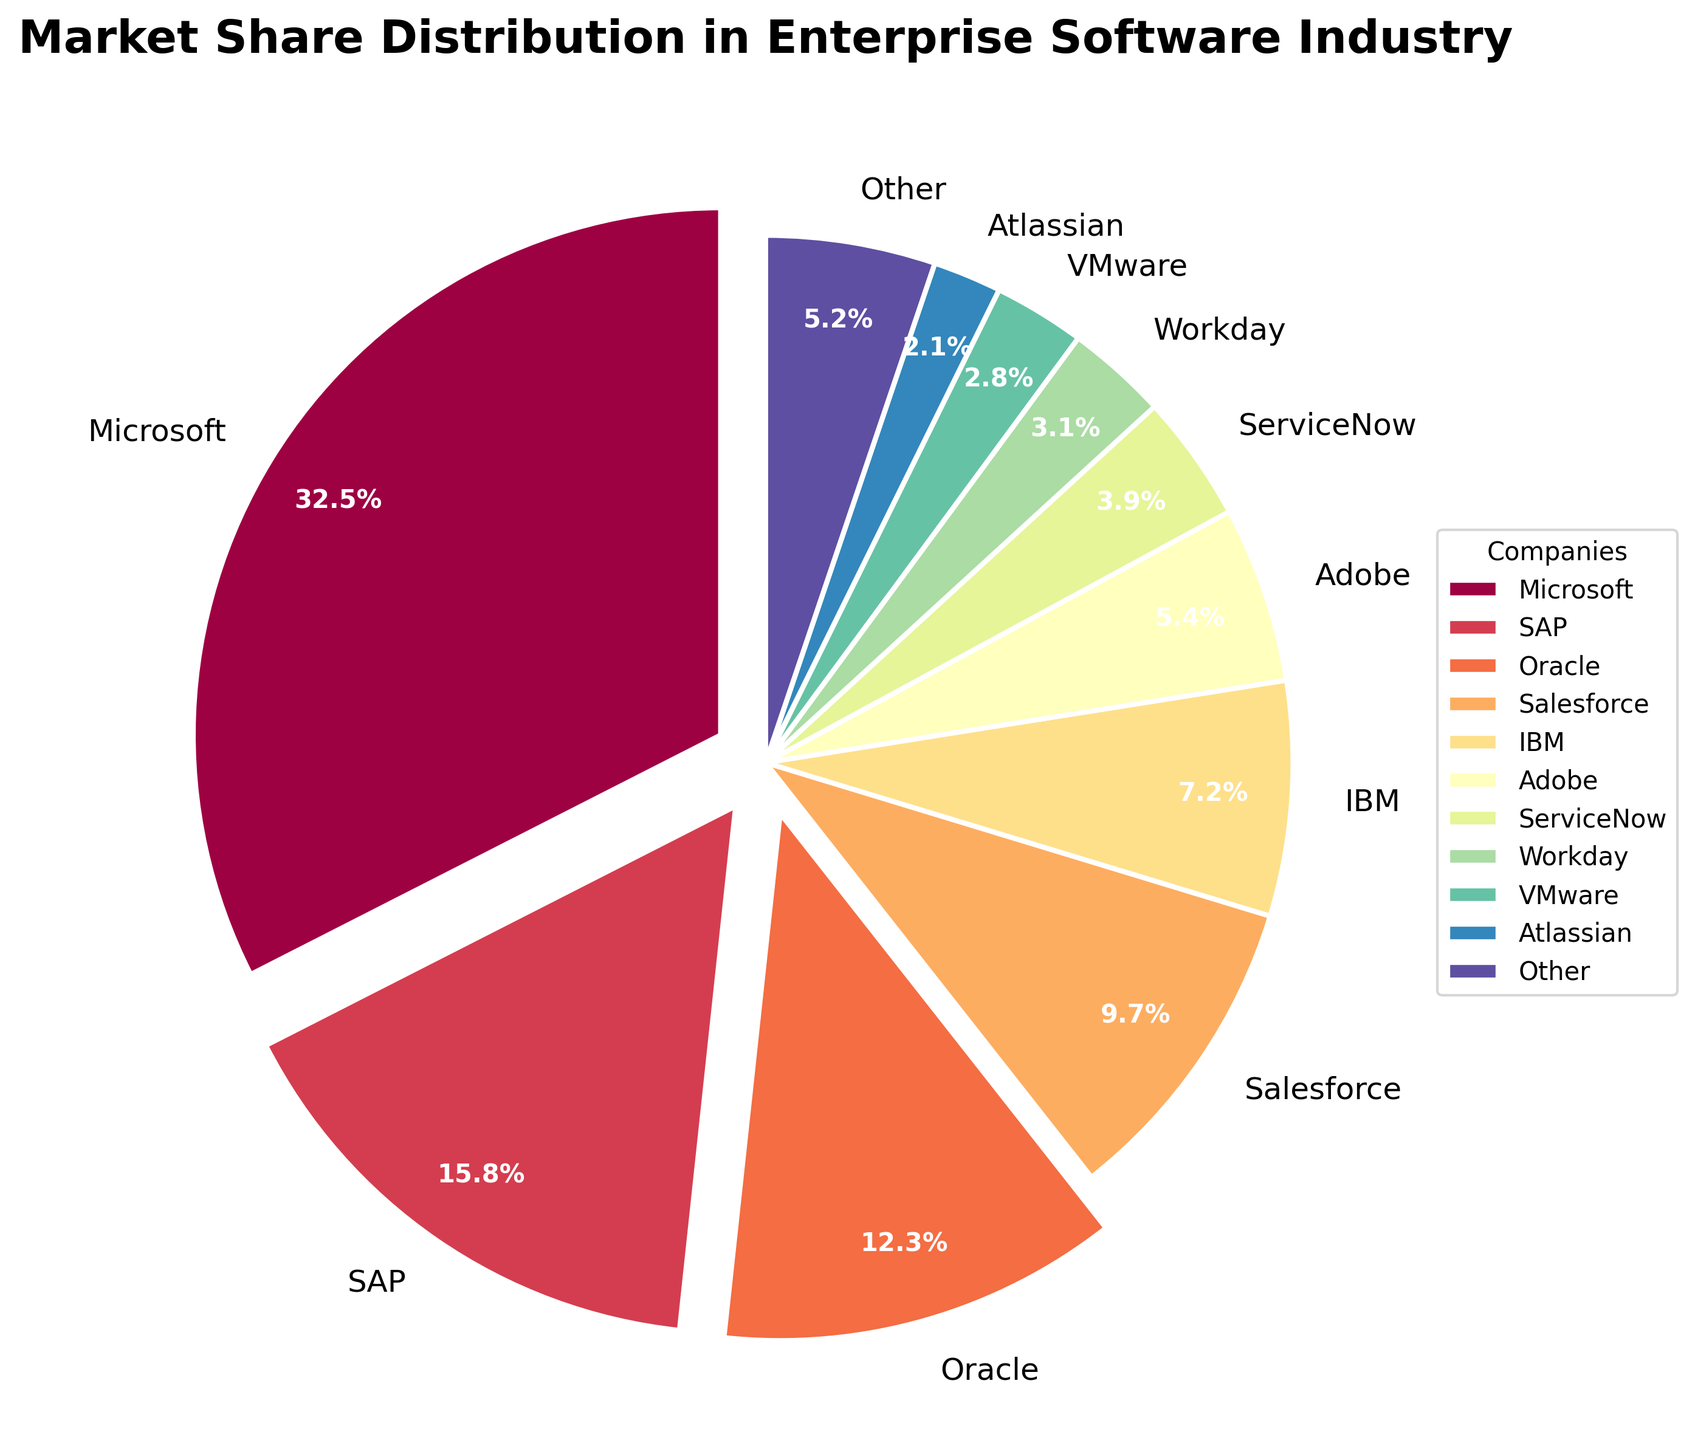What's the combined market share of the top three companies? The top three companies are Microsoft (32.5%), SAP (15.8%), and Oracle (12.3%). Adding their market shares together gives 32.5 + 15.8 + 12.3 = 60.6%.
Answer: 60.6% Which company has the lowest market share? Looking at the chart, Atlassian has the smallest slice, with a market share of 2.1%.
Answer: Atlassian What is the difference in market share between Microsoft and Salesforce? Microsoft has a market share of 32.5%, and Salesforce has 9.7%. The difference is 32.5 - 9.7 = 22.8%.
Answer: 22.8% Are there more companies with a market share above or below 5%? Companies with a market share above 5% are Microsoft, SAP, Oracle, Salesforce, and IBM. Companies with a market share below 5% are Adobe, ServiceNow, Workday, VMware, Atlassian, and Other. There are five companies above and six below 5%.
Answer: below Which company's market share slice is colored red? By looking for the red slice in the pie chart, we see that Oracle's slice is red.
Answer: Oracle What is the total market share of all companies other than Microsoft? The total market share excluding Microsoft is 15.8 + 12.3 + 9.7 + 7.2 + 5.4 + 3.9 + 3.1 + 2.8 + 2.1 + 5.2. Adding them together, we get 67.5%.
Answer: 67.5% Compare the combined market share of Adobe and ServiceNow to that of Salesforce. Adobe has a market share of 5.4%, and ServiceNow has 3.9%. Their combined market share is 5.4 + 3.9 = 9.3%. Salesforce has a market share of 9.7%, so 9.3% is less than 9.7%.
Answer: Salesforce has more Which company occupies roughly one-third of the market share? Microsoft holds 32.5% of the market share, which is roughly one-third (33.3%).
Answer: Microsoft By how much does IBM's market share fall short of 10%? IBM's market share is 7.2%. The difference from 10% is 10 - 7.2 = 2.8%.
Answer: 2.8% 